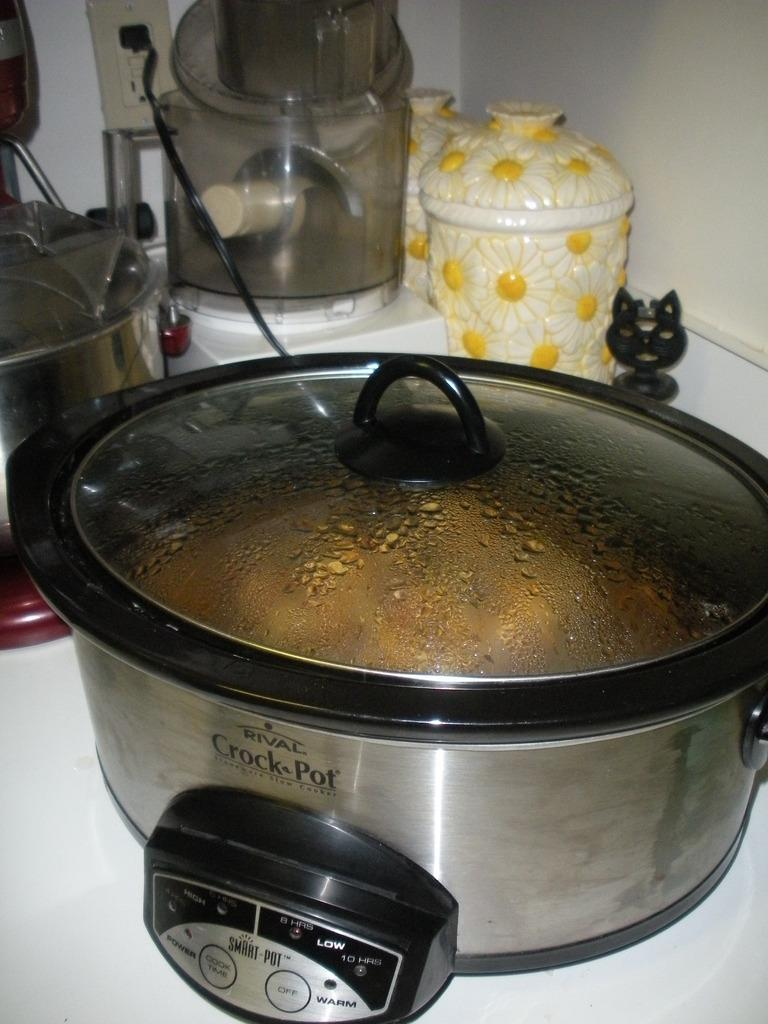<image>
Describe the image concisely. A rival brand silver colored crock pot on a counter. 